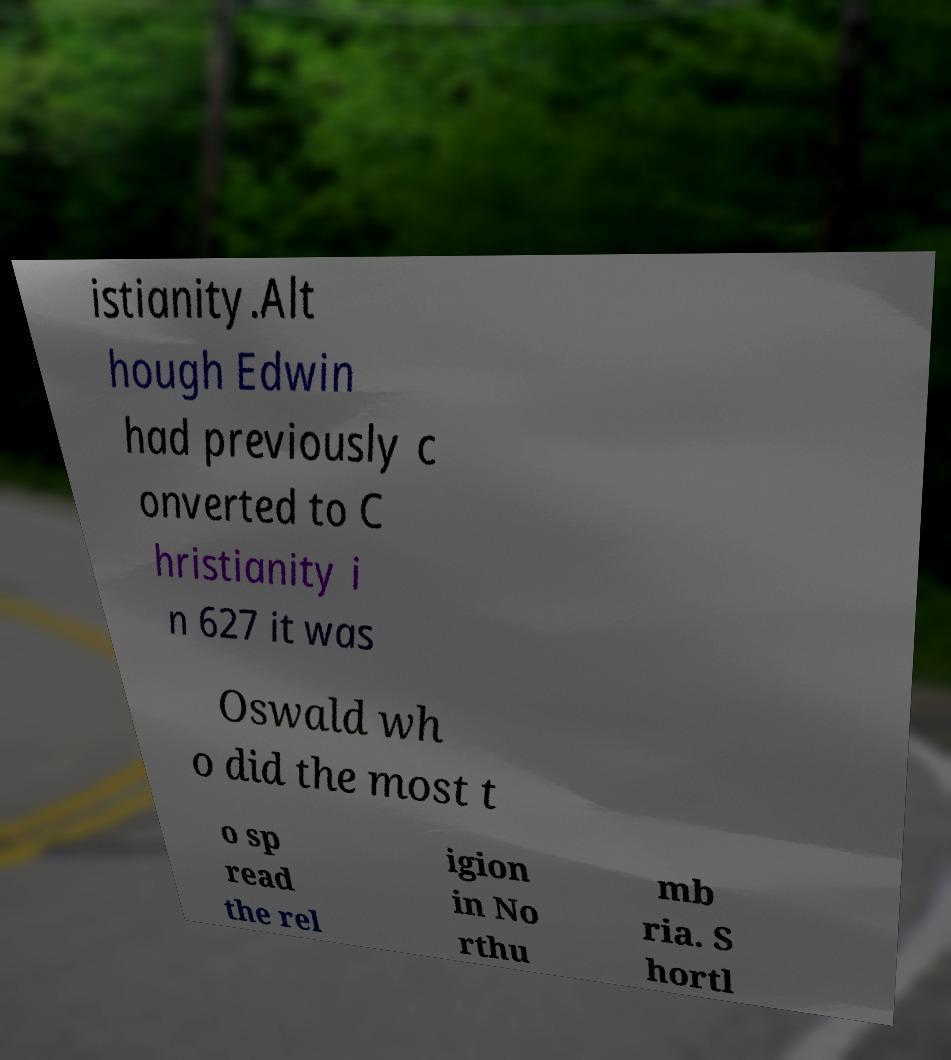Could you extract and type out the text from this image? istianity.Alt hough Edwin had previously c onverted to C hristianity i n 627 it was Oswald wh o did the most t o sp read the rel igion in No rthu mb ria. S hortl 